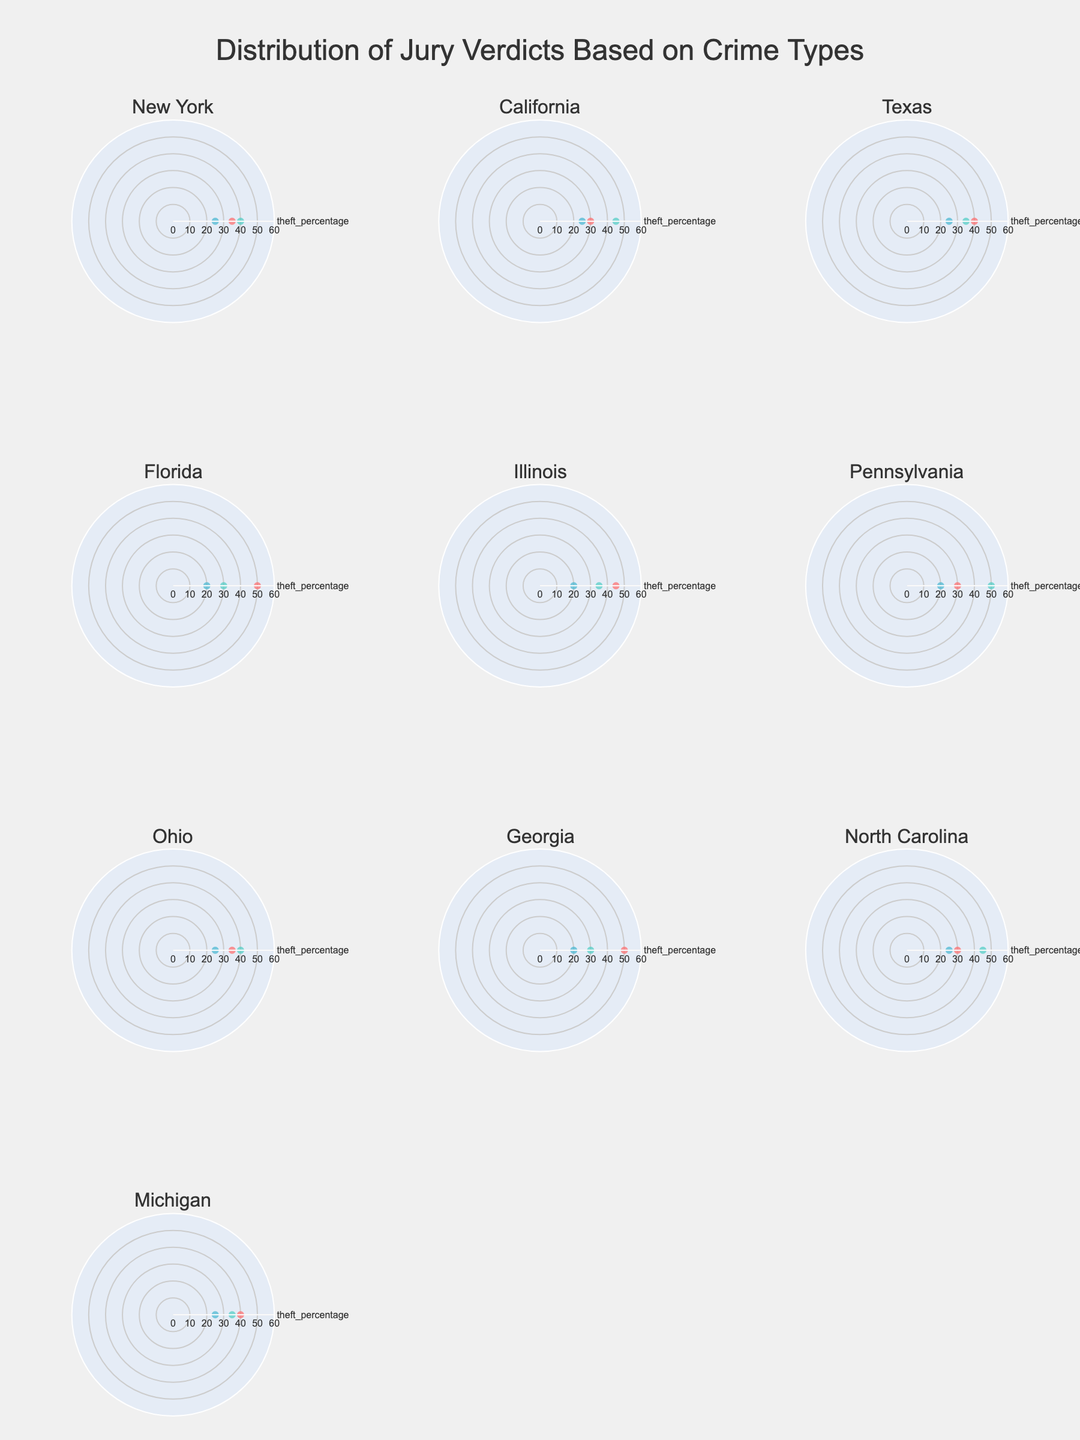What crime type has the highest verdict percentage in New York? By looking at New York's subplot, identify which crime type has the highest point on the polar chart. It shows that fraud has the highest percentage.
Answer: Fraud What is the range of theft percentages across all states? Check the min and max values of theft percentage across all state subplots. The minimum value is 30, and the maximum value is 50. So, the range is 50 - 30.
Answer: 20 Which state has the highest percentage of fraud verdicts? Compare the segment associated with fraud across all state subplots. Pennsylvania has the highest percentage at 50%.
Answer: Pennsylvania In which states are the theft and fraud percentages equal? Look for states where the segments for theft and fraud are the same height. No states show equal theft and fraud percentages.
Answer: None How many states have a higher percentage of theft than fraud? Count the subplots where the theft segment is higher than the fraud segment. New York, Texas, Michigan are the states where theft is higher than fraud.
Answer: 3 What's the mode of the homicide percentages? Find the most frequent percentile value for homicide across all states. 25% and 20% are frequent.
Answer: 25% Which state has an equal distribution of verdicts for theft, fraud, and homicide? Observe subplots for a state where all categories are equally distributed. No state shows equal distribution across all crimes.
Answer: None Are there any states where the homicide percentage is below 20%? Identify subplots where the homicide segment falls below 20%. This does not occur in any state mentioned in the figure.
Answer: No 